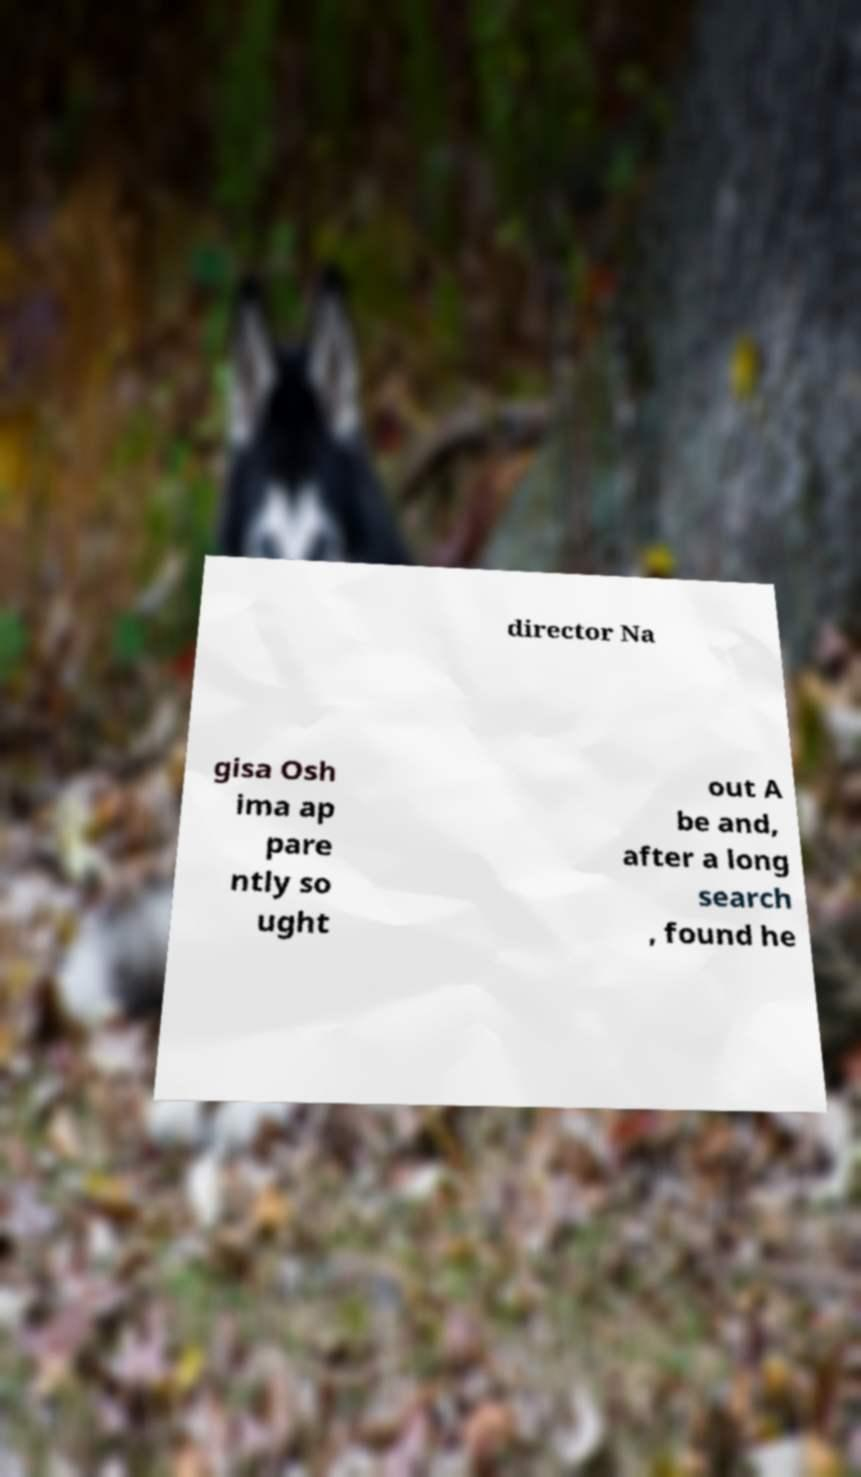For documentation purposes, I need the text within this image transcribed. Could you provide that? director Na gisa Osh ima ap pare ntly so ught out A be and, after a long search , found he 